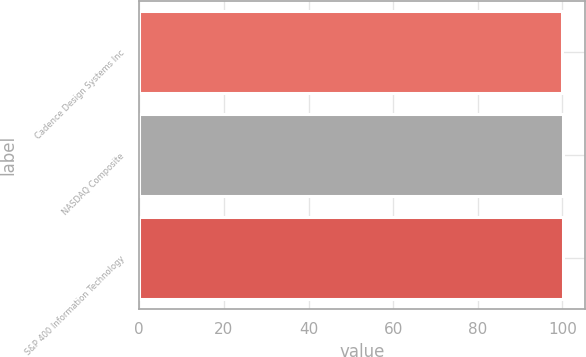Convert chart to OTSL. <chart><loc_0><loc_0><loc_500><loc_500><bar_chart><fcel>Cadence Design Systems Inc<fcel>NASDAQ Composite<fcel>S&P 400 Information Technology<nl><fcel>100<fcel>100.1<fcel>100.2<nl></chart> 